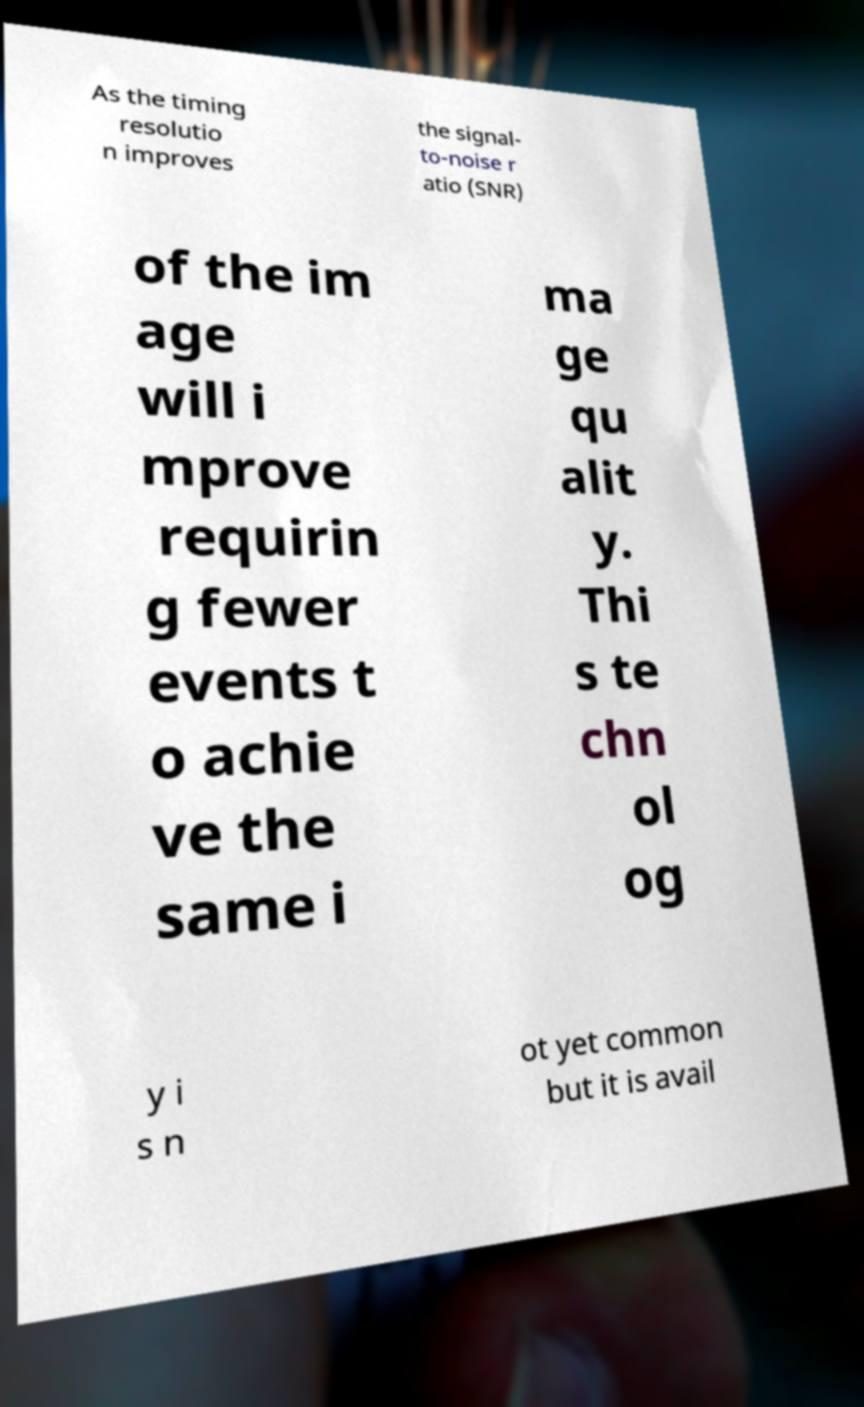Please read and relay the text visible in this image. What does it say? As the timing resolutio n improves the signal- to-noise r atio (SNR) of the im age will i mprove requirin g fewer events t o achie ve the same i ma ge qu alit y. Thi s te chn ol og y i s n ot yet common but it is avail 